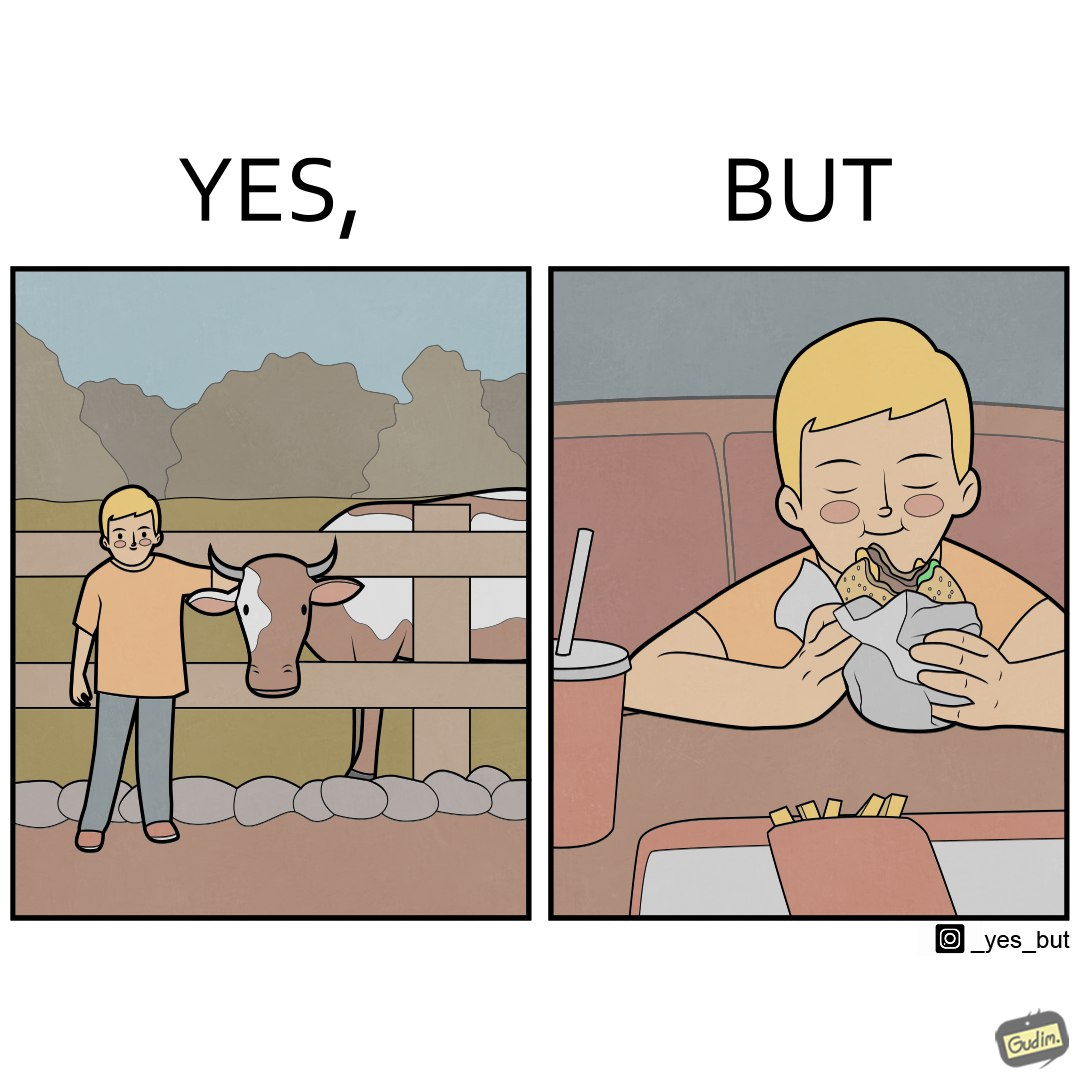Describe what you see in this image. The irony is that the boy is petting the cow to show that he cares about the animal, but then he also eats hamburgers made from the same cows 